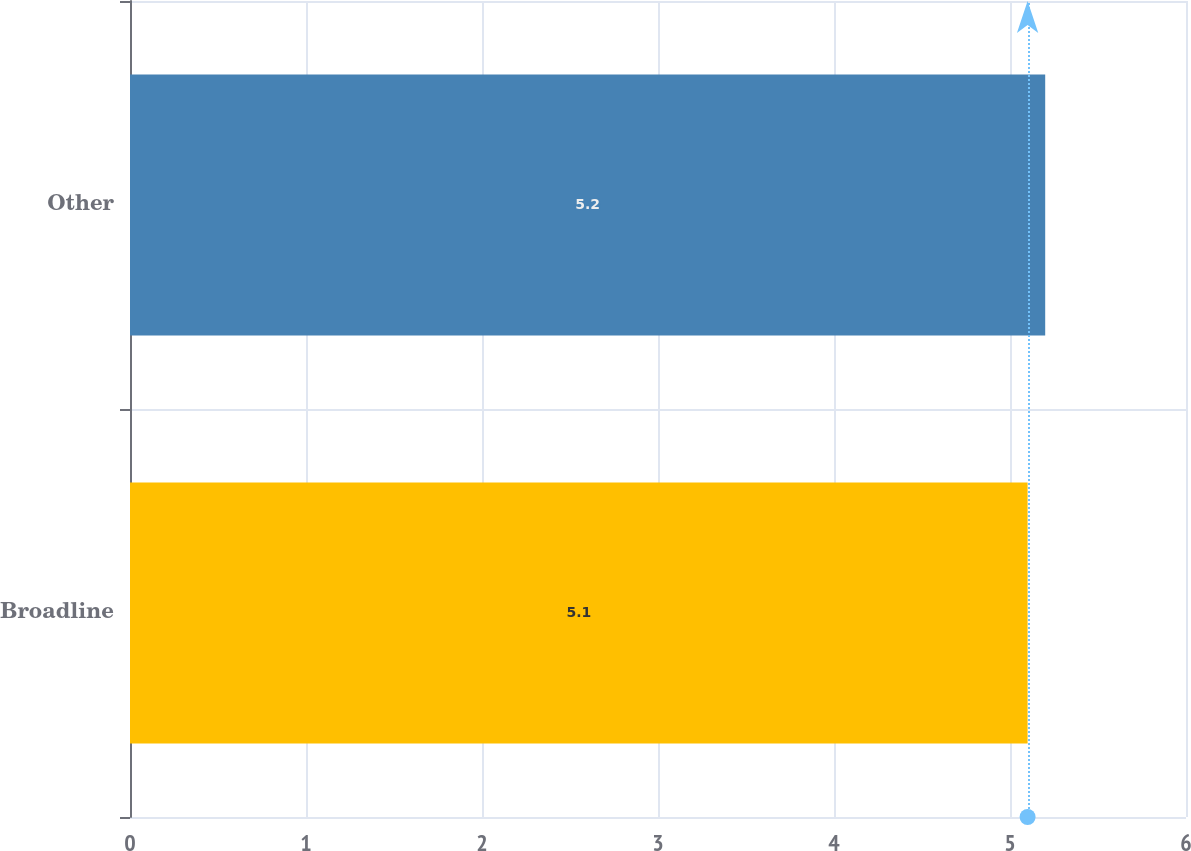<chart> <loc_0><loc_0><loc_500><loc_500><bar_chart><fcel>Broadline<fcel>Other<nl><fcel>5.1<fcel>5.2<nl></chart> 